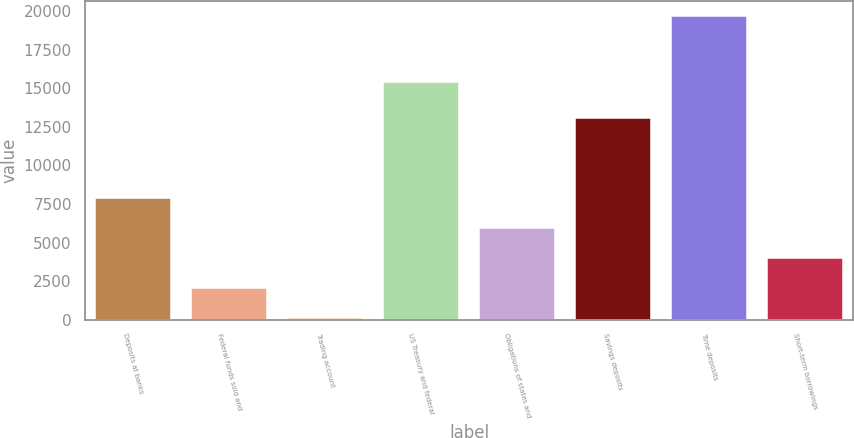Convert chart. <chart><loc_0><loc_0><loc_500><loc_500><bar_chart><fcel>Deposits at banks<fcel>Federal funds sold and<fcel>Trading account<fcel>US Treasury and federal<fcel>Obligations of states and<fcel>Savings deposits<fcel>Time deposits<fcel>Short-term borrowings<nl><fcel>7918<fcel>2045.5<fcel>88<fcel>15379<fcel>5960.5<fcel>13063<fcel>19663<fcel>4003<nl></chart> 